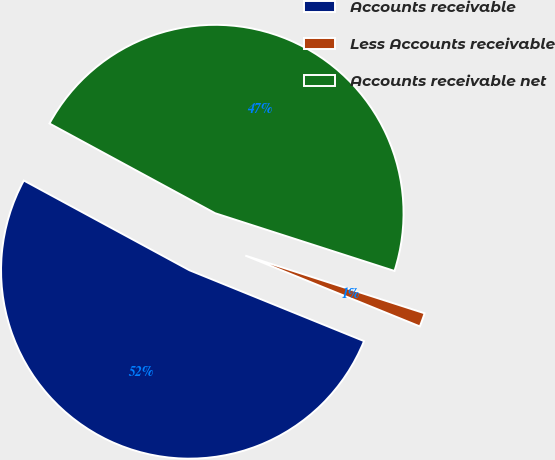<chart> <loc_0><loc_0><loc_500><loc_500><pie_chart><fcel>Accounts receivable<fcel>Less Accounts receivable<fcel>Accounts receivable net<nl><fcel>51.76%<fcel>1.18%<fcel>47.05%<nl></chart> 